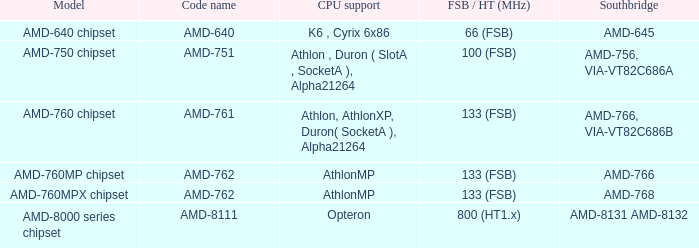What is the code name when the FSB / HT (MHz) is 100 (fsb)? AMD-751. Parse the full table. {'header': ['Model', 'Code name', 'CPU support', 'FSB / HT (MHz)', 'Southbridge'], 'rows': [['AMD-640 chipset', 'AMD-640', 'K6 , Cyrix 6x86', '66 (FSB)', 'AMD-645'], ['AMD-750 chipset', 'AMD-751', 'Athlon , Duron ( SlotA , SocketA ), Alpha21264', '100 (FSB)', 'AMD-756, VIA-VT82C686A'], ['AMD-760 chipset', 'AMD-761', 'Athlon, AthlonXP, Duron( SocketA ), Alpha21264', '133 (FSB)', 'AMD-766, VIA-VT82C686B'], ['AMD-760MP chipset', 'AMD-762', 'AthlonMP', '133 (FSB)', 'AMD-766'], ['AMD-760MPX chipset', 'AMD-762', 'AthlonMP', '133 (FSB)', 'AMD-768'], ['AMD-8000 series chipset', 'AMD-8111', 'Opteron', '800 (HT1.x)', 'AMD-8131 AMD-8132']]} 